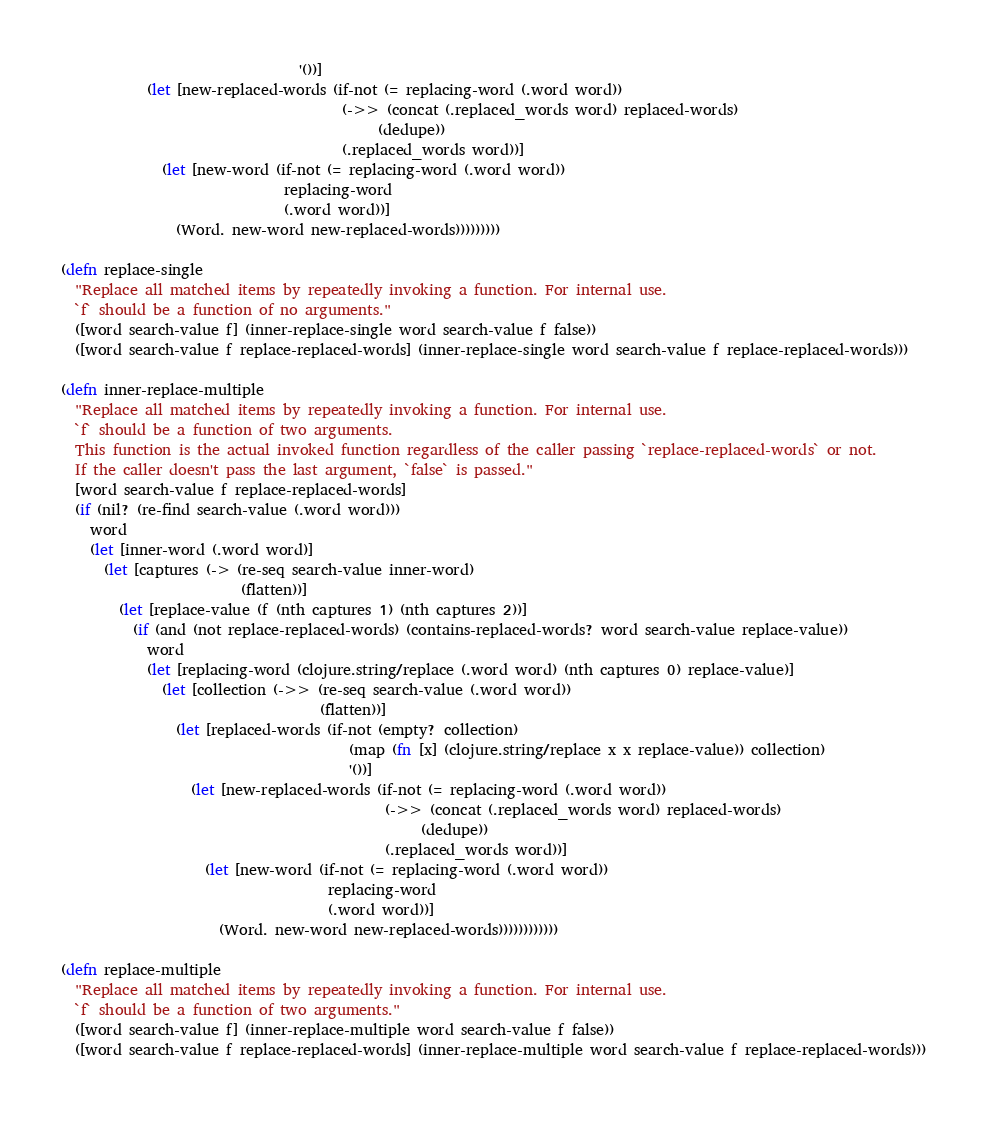Convert code to text. <code><loc_0><loc_0><loc_500><loc_500><_Clojure_>                                 '())]
            (let [new-replaced-words (if-not (= replacing-word (.word word))
                                       (->> (concat (.replaced_words word) replaced-words)
                                            (dedupe))
                                       (.replaced_words word))]
              (let [new-word (if-not (= replacing-word (.word word))
                               replacing-word
                               (.word word))]
                (Word. new-word new-replaced-words)))))))))

(defn replace-single
  "Replace all matched items by repeatedly invoking a function. For internal use.
  `f` should be a function of no arguments."
  ([word search-value f] (inner-replace-single word search-value f false))
  ([word search-value f replace-replaced-words] (inner-replace-single word search-value f replace-replaced-words)))

(defn inner-replace-multiple
  "Replace all matched items by repeatedly invoking a function. For internal use.
  `f` should be a function of two arguments.
  This function is the actual invoked function regardless of the caller passing `replace-replaced-words` or not.
  If the caller doesn't pass the last argument, `false` is passed."
  [word search-value f replace-replaced-words]
  (if (nil? (re-find search-value (.word word)))
    word
    (let [inner-word (.word word)]
      (let [captures (-> (re-seq search-value inner-word)
                         (flatten))]
        (let [replace-value (f (nth captures 1) (nth captures 2))]
          (if (and (not replace-replaced-words) (contains-replaced-words? word search-value replace-value))
            word
            (let [replacing-word (clojure.string/replace (.word word) (nth captures 0) replace-value)]
              (let [collection (->> (re-seq search-value (.word word))
                                    (flatten))]
                (let [replaced-words (if-not (empty? collection)
                                        (map (fn [x] (clojure.string/replace x x replace-value)) collection)
                                        '())]
                  (let [new-replaced-words (if-not (= replacing-word (.word word))
                                             (->> (concat (.replaced_words word) replaced-words)
                                                  (dedupe))
                                             (.replaced_words word))]
                    (let [new-word (if-not (= replacing-word (.word word))
                                     replacing-word
                                     (.word word))]
                      (Word. new-word new-replaced-words))))))))))))

(defn replace-multiple
  "Replace all matched items by repeatedly invoking a function. For internal use.
  `f` should be a function of two arguments."
  ([word search-value f] (inner-replace-multiple word search-value f false))
  ([word search-value f replace-replaced-words] (inner-replace-multiple word search-value f replace-replaced-words)))</code> 